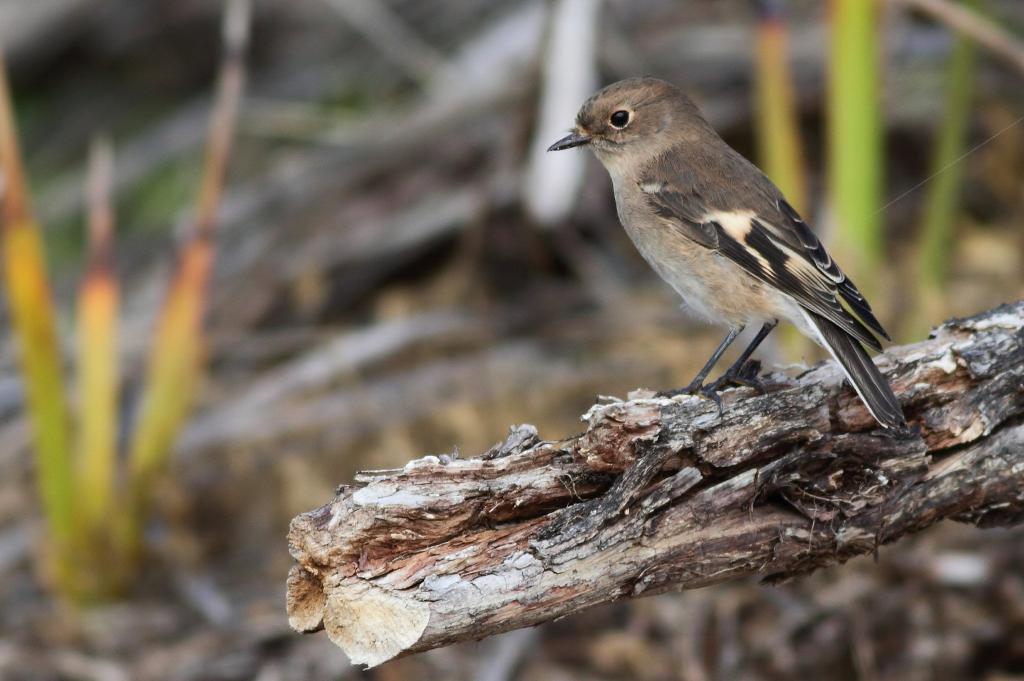Can you describe this image briefly? In the foreground of this image, there is a bird on the wood. In the background, there are two plants and remaining are unclear. 